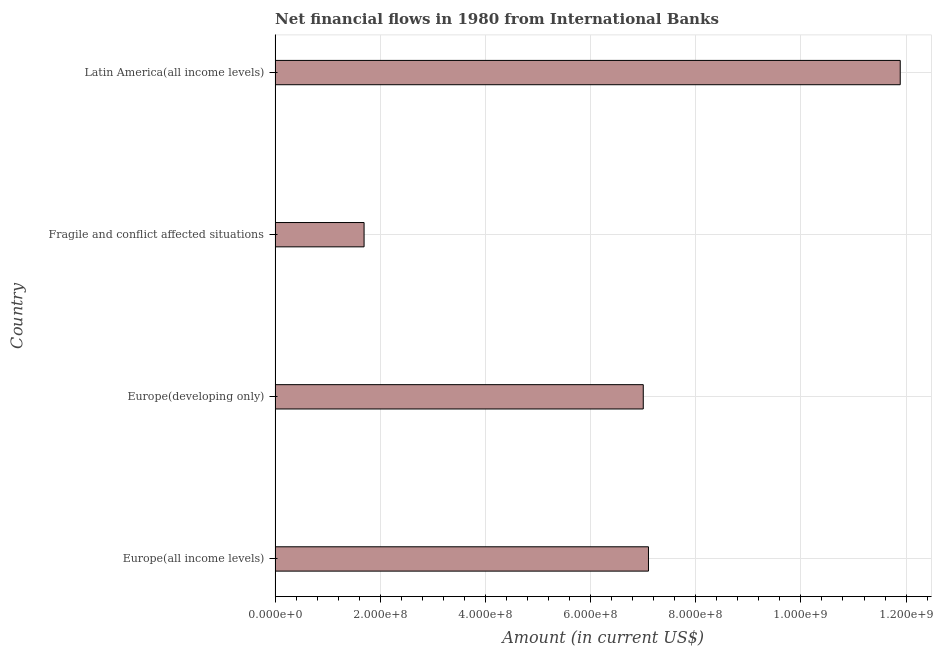Does the graph contain any zero values?
Your answer should be compact. No. What is the title of the graph?
Your answer should be compact. Net financial flows in 1980 from International Banks. What is the label or title of the Y-axis?
Provide a succinct answer. Country. What is the net financial flows from ibrd in Europe(all income levels)?
Your response must be concise. 7.10e+08. Across all countries, what is the maximum net financial flows from ibrd?
Your response must be concise. 1.19e+09. Across all countries, what is the minimum net financial flows from ibrd?
Keep it short and to the point. 1.69e+08. In which country was the net financial flows from ibrd maximum?
Offer a terse response. Latin America(all income levels). In which country was the net financial flows from ibrd minimum?
Your response must be concise. Fragile and conflict affected situations. What is the sum of the net financial flows from ibrd?
Provide a succinct answer. 2.77e+09. What is the difference between the net financial flows from ibrd in Europe(developing only) and Latin America(all income levels)?
Make the answer very short. -4.89e+08. What is the average net financial flows from ibrd per country?
Give a very brief answer. 6.92e+08. What is the median net financial flows from ibrd?
Ensure brevity in your answer.  7.05e+08. In how many countries, is the net financial flows from ibrd greater than 1120000000 US$?
Your answer should be compact. 1. What is the ratio of the net financial flows from ibrd in Europe(all income levels) to that in Fragile and conflict affected situations?
Offer a very short reply. 4.2. Is the net financial flows from ibrd in Europe(developing only) less than that in Latin America(all income levels)?
Give a very brief answer. Yes. Is the difference between the net financial flows from ibrd in Europe(all income levels) and Latin America(all income levels) greater than the difference between any two countries?
Your answer should be very brief. No. What is the difference between the highest and the second highest net financial flows from ibrd?
Ensure brevity in your answer.  4.79e+08. Is the sum of the net financial flows from ibrd in Europe(all income levels) and Fragile and conflict affected situations greater than the maximum net financial flows from ibrd across all countries?
Ensure brevity in your answer.  No. What is the difference between the highest and the lowest net financial flows from ibrd?
Your answer should be compact. 1.02e+09. In how many countries, is the net financial flows from ibrd greater than the average net financial flows from ibrd taken over all countries?
Your answer should be very brief. 3. How many countries are there in the graph?
Your answer should be very brief. 4. Are the values on the major ticks of X-axis written in scientific E-notation?
Make the answer very short. Yes. What is the Amount (in current US$) in Europe(all income levels)?
Your answer should be very brief. 7.10e+08. What is the Amount (in current US$) in Europe(developing only)?
Your answer should be very brief. 7.00e+08. What is the Amount (in current US$) in Fragile and conflict affected situations?
Make the answer very short. 1.69e+08. What is the Amount (in current US$) of Latin America(all income levels)?
Offer a very short reply. 1.19e+09. What is the difference between the Amount (in current US$) in Europe(all income levels) and Europe(developing only)?
Make the answer very short. 9.90e+06. What is the difference between the Amount (in current US$) in Europe(all income levels) and Fragile and conflict affected situations?
Ensure brevity in your answer.  5.41e+08. What is the difference between the Amount (in current US$) in Europe(all income levels) and Latin America(all income levels)?
Ensure brevity in your answer.  -4.79e+08. What is the difference between the Amount (in current US$) in Europe(developing only) and Fragile and conflict affected situations?
Make the answer very short. 5.31e+08. What is the difference between the Amount (in current US$) in Europe(developing only) and Latin America(all income levels)?
Offer a very short reply. -4.89e+08. What is the difference between the Amount (in current US$) in Fragile and conflict affected situations and Latin America(all income levels)?
Offer a very short reply. -1.02e+09. What is the ratio of the Amount (in current US$) in Europe(all income levels) to that in Fragile and conflict affected situations?
Give a very brief answer. 4.2. What is the ratio of the Amount (in current US$) in Europe(all income levels) to that in Latin America(all income levels)?
Offer a terse response. 0.6. What is the ratio of the Amount (in current US$) in Europe(developing only) to that in Fragile and conflict affected situations?
Your answer should be compact. 4.14. What is the ratio of the Amount (in current US$) in Europe(developing only) to that in Latin America(all income levels)?
Your response must be concise. 0.59. What is the ratio of the Amount (in current US$) in Fragile and conflict affected situations to that in Latin America(all income levels)?
Your response must be concise. 0.14. 